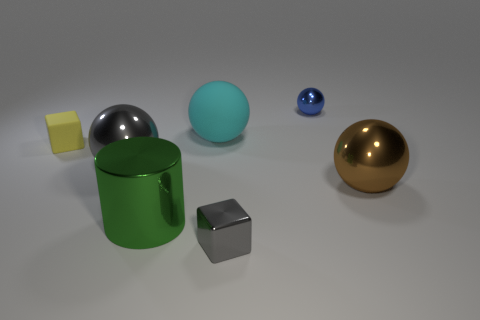There is a small block behind the gray object to the right of the gray metallic ball; what number of metal cubes are to the left of it?
Your answer should be very brief. 0. What is the color of the shiny thing that is both behind the big brown metal thing and right of the gray ball?
Offer a very short reply. Blue. What number of metal things have the same color as the metallic block?
Give a very brief answer. 1. How many cylinders are big shiny objects or tiny rubber things?
Give a very brief answer. 1. What is the color of the other matte object that is the same size as the brown thing?
Make the answer very short. Cyan. There is a tiny metal thing that is in front of the large metallic object right of the green object; is there a matte cube right of it?
Keep it short and to the point. No. How big is the blue object?
Provide a succinct answer. Small. What number of things are either big gray shiny spheres or yellow objects?
Provide a succinct answer. 2. What color is the small block that is made of the same material as the large cyan thing?
Keep it short and to the point. Yellow. Do the gray object that is on the left side of the rubber ball and the small yellow rubber object have the same shape?
Provide a short and direct response. No. 